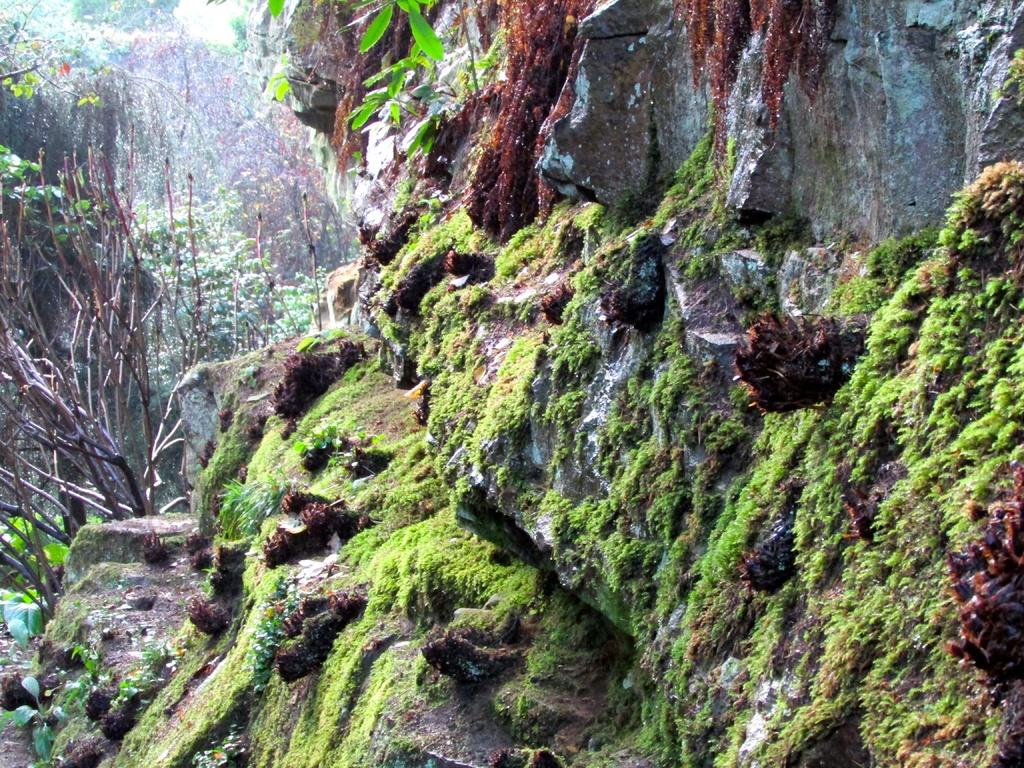What type of natural elements can be seen in the image? There are rocks and grass in the image. What is growing on the rocks? Grass is growing on the rocks. What can be seen in the background of the image? There are trees and plants in the background of the image. Can you see the queen saying good-bye to the bee in the image? There is no queen or bee present in the image. 